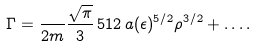<formula> <loc_0><loc_0><loc_500><loc_500>\Gamma = \frac { } { 2 m } \frac { \sqrt { \pi } } { 3 } \, 5 1 2 \, a ( \epsilon ) ^ { 5 / 2 } \rho ^ { 3 / 2 } + \dots .</formula> 